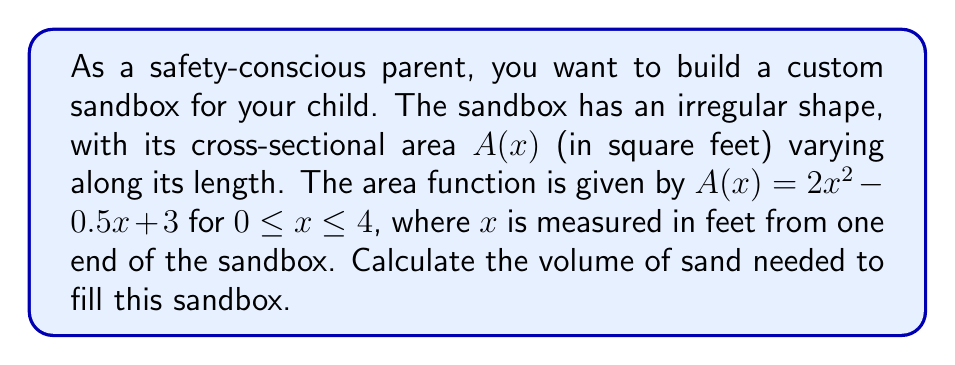Can you solve this math problem? To find the volume of the irregularly shaped sandbox, we need to use integration techniques. The volume of a solid with a variable cross-sectional area can be calculated using the following steps:

1. Identify the function for the cross-sectional area: $A(x) = 2x^2 - 0.5x + 3$

2. Determine the limits of integration: $x$ varies from 0 to 4 feet.

3. Set up the integral for volume:
   $$V = \int_0^4 A(x) dx = \int_0^4 (2x^2 - 0.5x + 3) dx$$

4. Integrate the function:
   $$V = \int_0^4 (2x^2 - 0.5x + 3) dx$$
   $$= \left[\frac{2x^3}{3} - \frac{0.5x^2}{2} + 3x\right]_0^4$$

5. Evaluate the integral:
   $$V = \left(\frac{2(4^3)}{3} - \frac{0.5(4^2)}{2} + 3(4)\right) - \left(\frac{2(0^3)}{3} - \frac{0.5(0^2)}{2} + 3(0)\right)$$
   $$= \left(\frac{128}{3} - 4 + 12\right) - (0)$$
   $$= \frac{128}{3} + 8 = \frac{152}{3}$$

Therefore, the volume of the sandbox is $\frac{152}{3}$ cubic feet.
Answer: $\frac{152}{3}$ cubic feet 